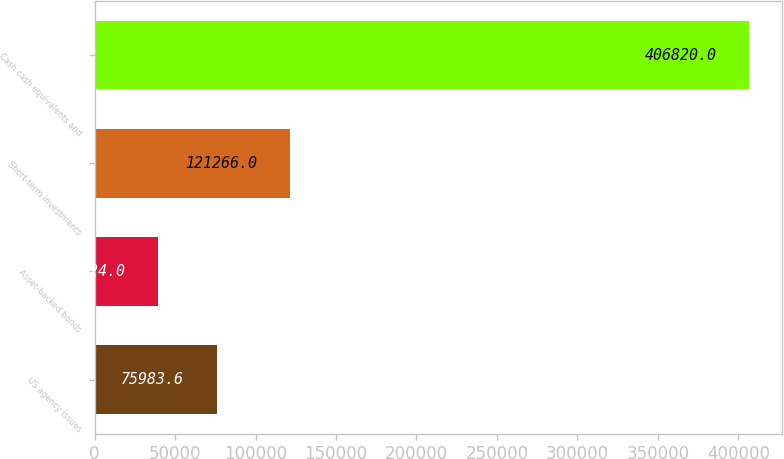<chart> <loc_0><loc_0><loc_500><loc_500><bar_chart><fcel>US agency issues<fcel>Asset-backed bonds<fcel>Short-term investments<fcel>Cash cash equivalents and<nl><fcel>75983.6<fcel>39224<fcel>121266<fcel>406820<nl></chart> 